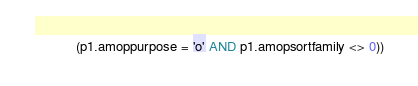Convert code to text. <code><loc_0><loc_0><loc_500><loc_500><_SQL_>           (p1.amoppurpose = 'o' AND p1.amopsortfamily <> 0))
</code> 